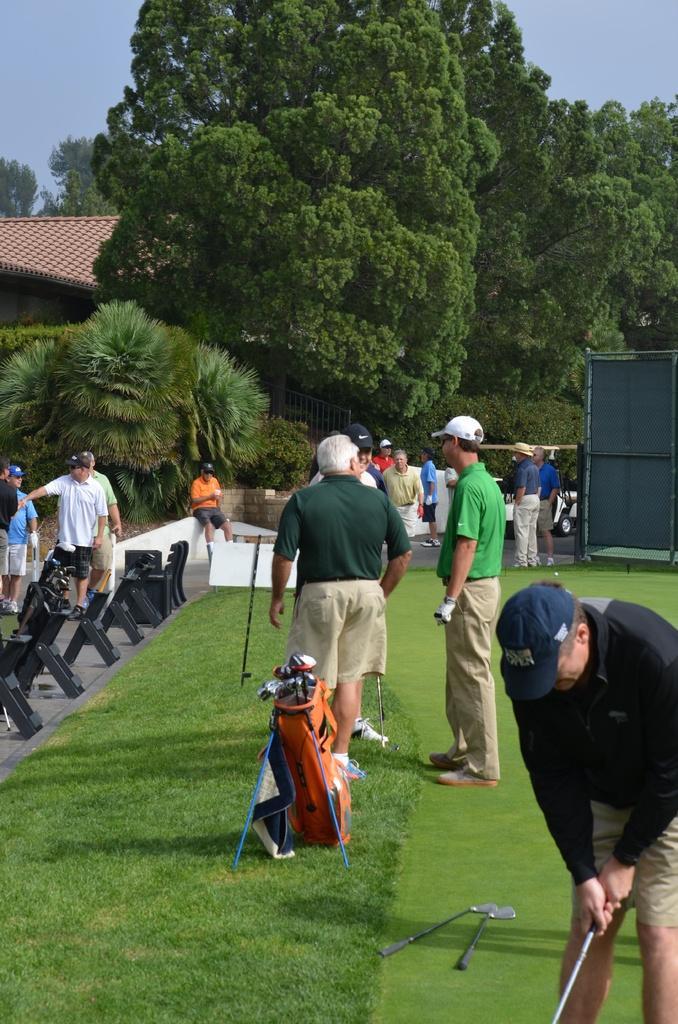Describe this image in one or two sentences. In this image I can see group of people standing. In front the person is wearing black and brown color dress and holding some object. In the background I can see the shed, few trees in green color and the sky is in blue color. 